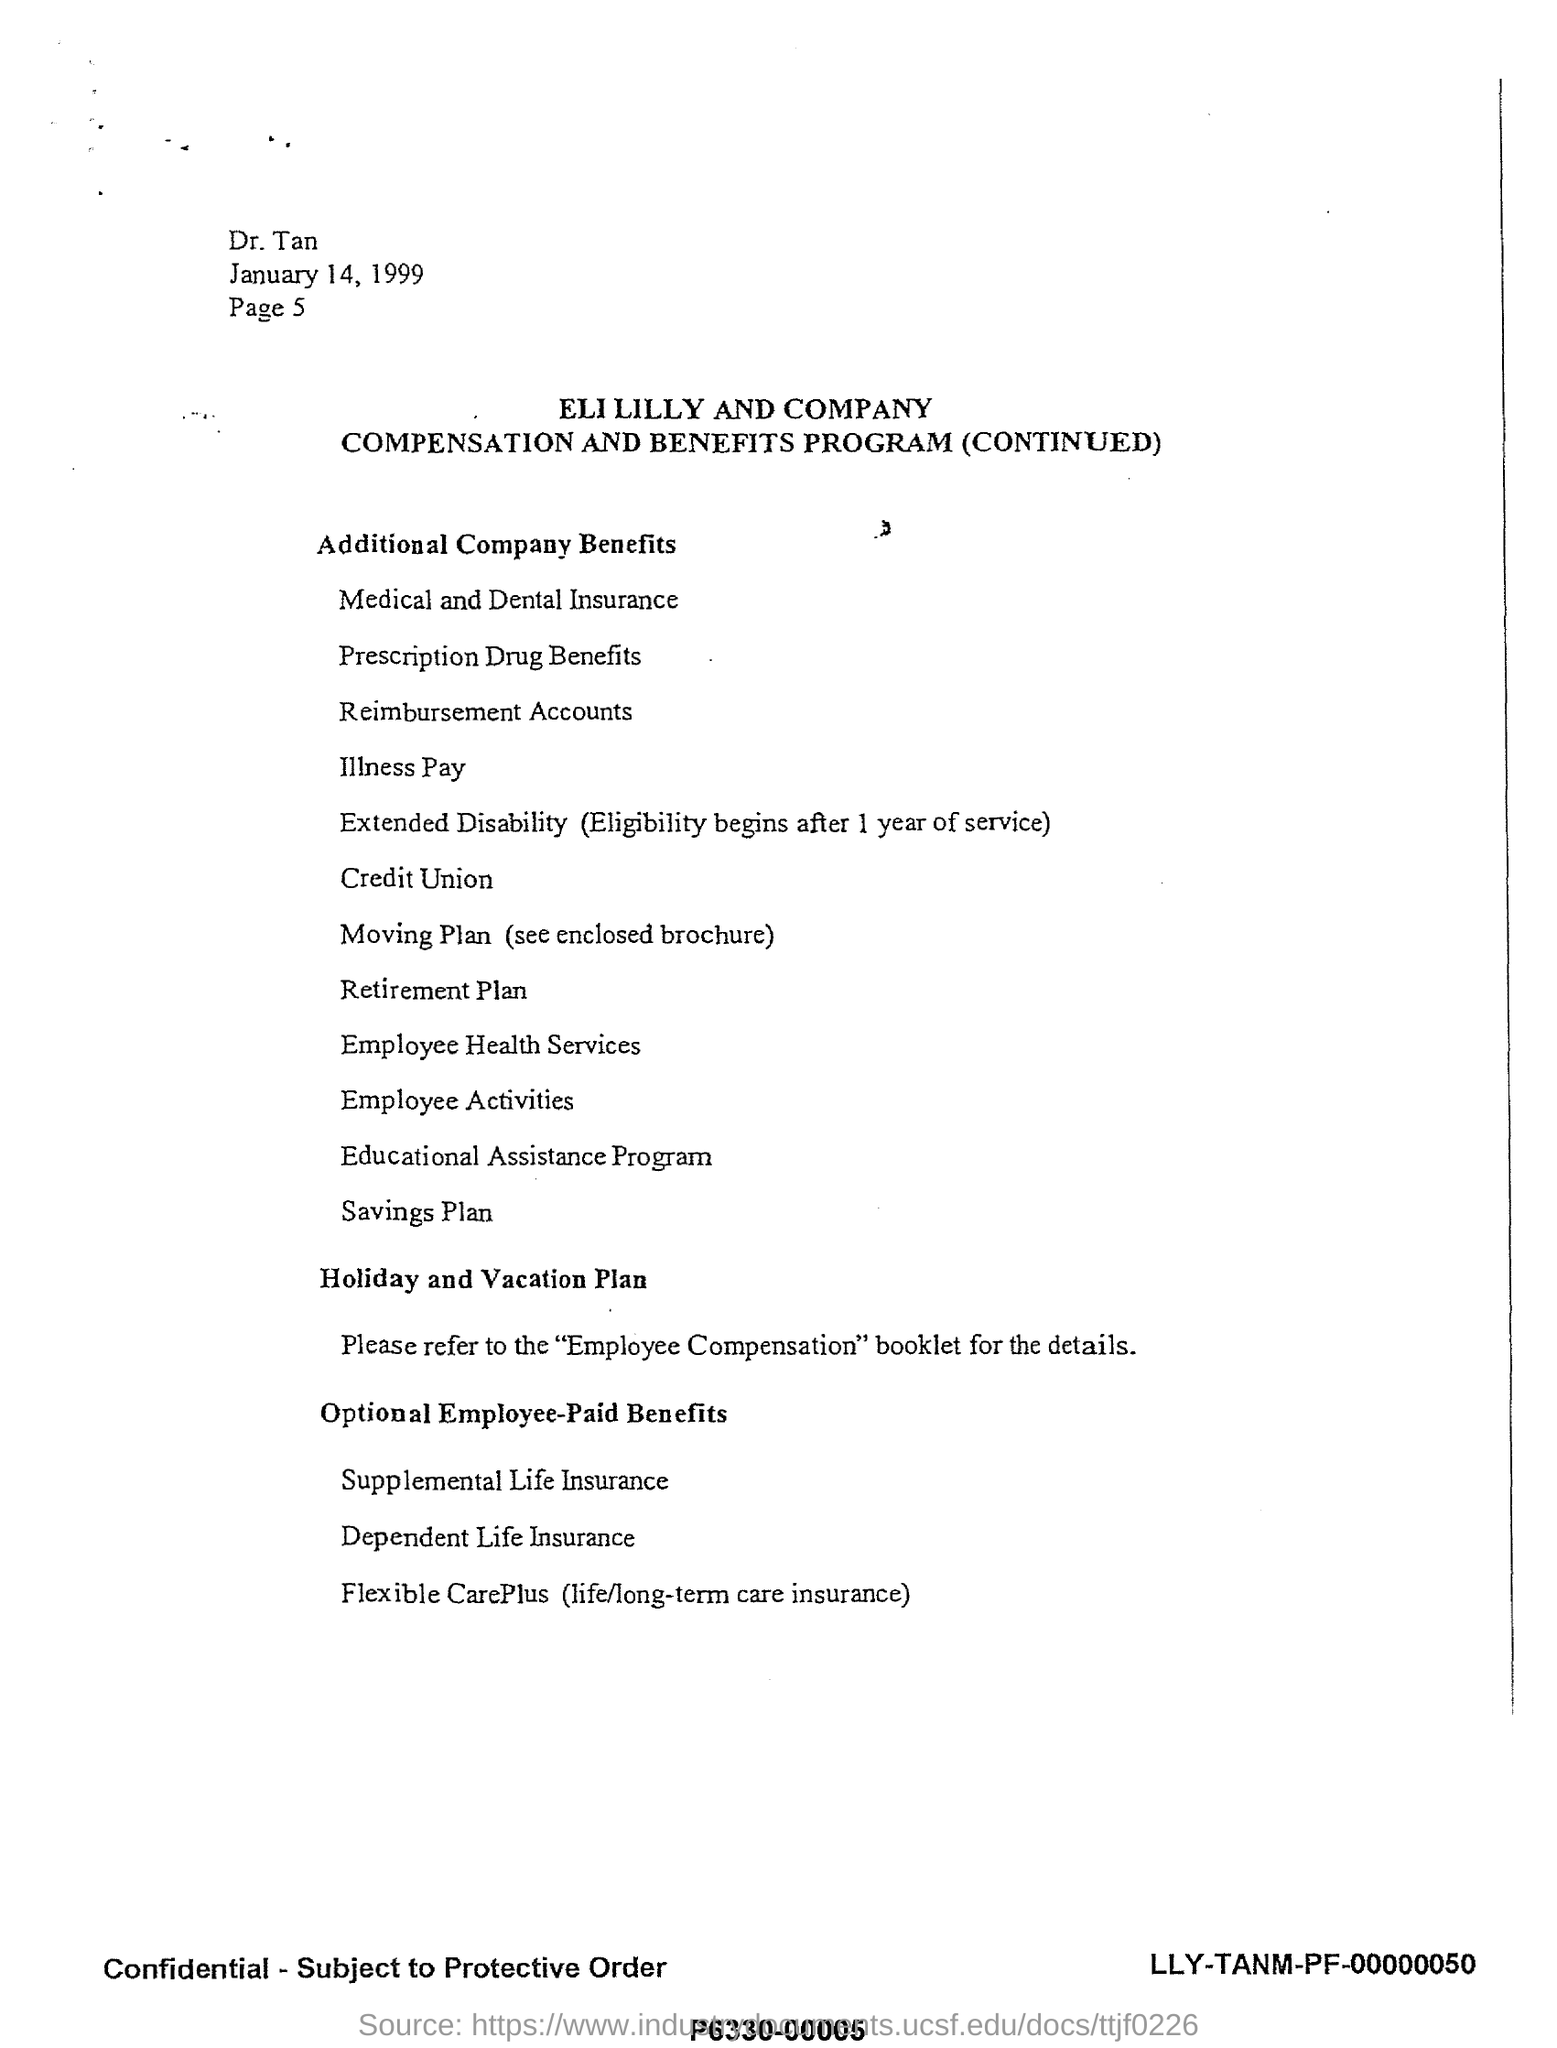Give some essential details in this illustration. The company name is ELI LILLY AND COMPANY. The benefit that begins after one year of service is extended disability. The date mentioned is January 14, 1999. 